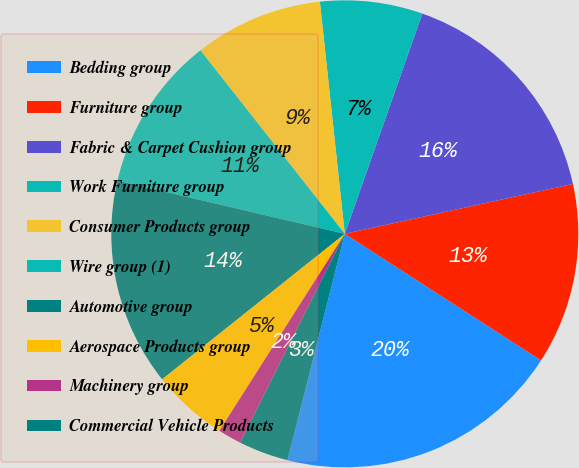Convert chart to OTSL. <chart><loc_0><loc_0><loc_500><loc_500><pie_chart><fcel>Bedding group<fcel>Furniture group<fcel>Fabric & Carpet Cushion group<fcel>Work Furniture group<fcel>Consumer Products group<fcel>Wire group (1)<fcel>Automotive group<fcel>Aerospace Products group<fcel>Machinery group<fcel>Commercial Vehicle Products<nl><fcel>19.83%<fcel>12.55%<fcel>16.19%<fcel>7.09%<fcel>8.91%<fcel>10.73%<fcel>14.37%<fcel>5.27%<fcel>1.63%<fcel>3.45%<nl></chart> 